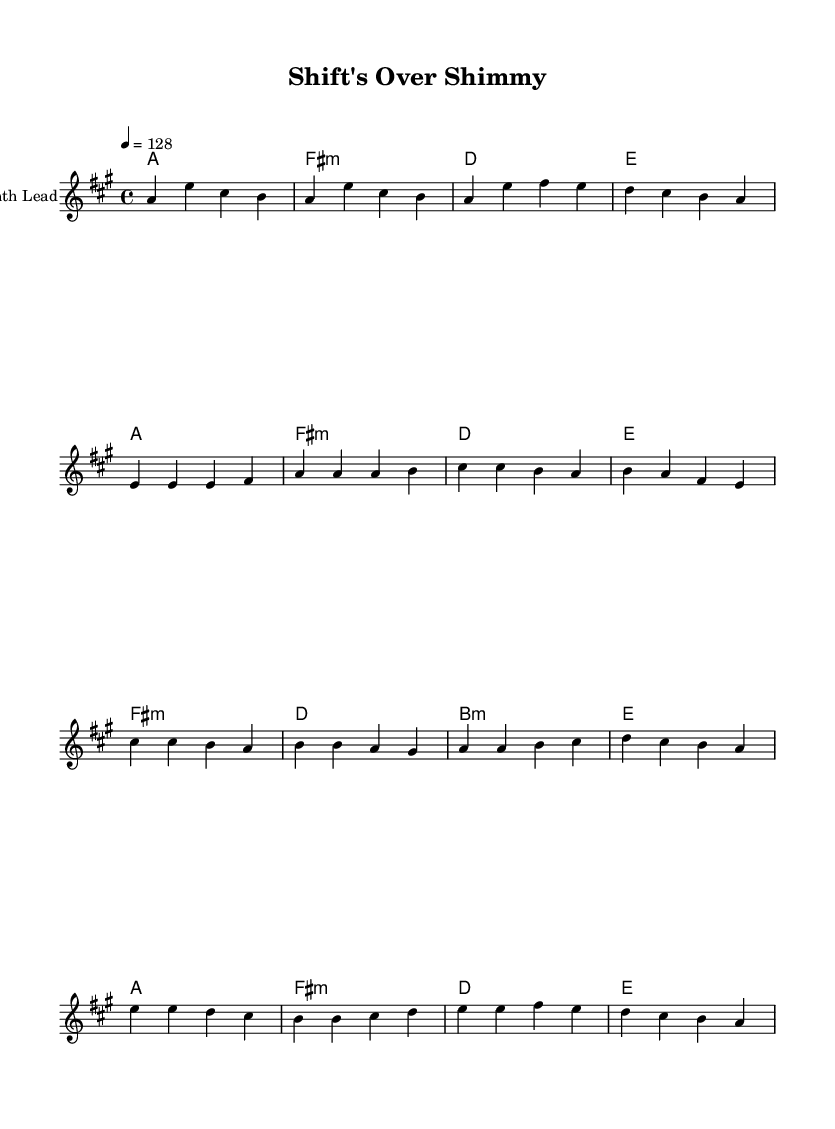What is the key signature of this music? The key signature is A major, indicated by three sharps (F#, C#, and G#) at the beginning of the staff.
Answer: A major What is the time signature of this music? The time signature is 4/4, which is shown at the beginning of the score, indicating that there are four beats per measure.
Answer: 4/4 What is the tempo marking of this piece? The tempo marking is 128 beats per minute, specified under the global settings for the tempo.
Answer: 128 How many measures are in the melody section? The melody consists of 16 measures in total, which can be counted from the start to the end of the provided melody section.
Answer: 16 What chord follows the introduction? The chord that follows the introduction is A major, which is the first chord in both the introduction and verse sections.
Answer: A Which part of the music is likely the highlight or the most energetic section? The chorus section is often the highlight in K-Pop tracks, and here it is clearly marked and contains more rhythmic energy compared to the verses.
Answer: Chorus What is the relationship between the Verse and the Pre-Chorus? The Pre-Chorus features a build-up to the Chorus, often using similar melodic patterns but rising in intensity and harmonic support, creating anticipation for the next section.
Answer: Build-up 